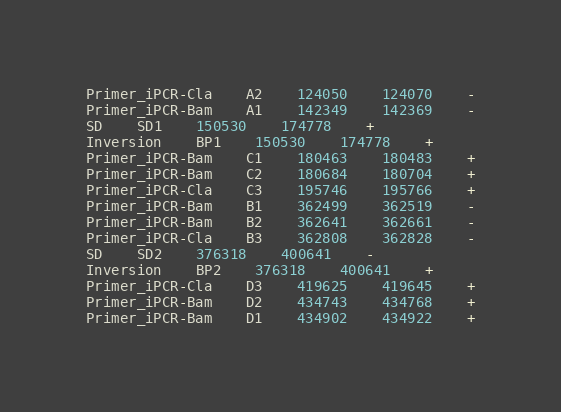<code> <loc_0><loc_0><loc_500><loc_500><_SQL_>Primer_iPCR-Cla	A2	124050	124070	-
Primer_iPCR-Bam	A1	142349	142369	-
SD	SD1	150530	174778	+
Inversion	BP1	150530	174778	+
Primer_iPCR-Bam	C1	180463	180483	+
Primer_iPCR-Bam	C2	180684	180704	+
Primer_iPCR-Cla	C3	195746	195766	+
Primer_iPCR-Bam	B1	362499	362519	-
Primer_iPCR-Bam	B2	362641	362661	-
Primer_iPCR-Cla	B3	362808	362828	-
SD	SD2	376318	400641	-
Inversion	BP2	376318	400641	+
Primer_iPCR-Cla	D3	419625	419645	+
Primer_iPCR-Bam	D2	434743	434768	+
Primer_iPCR-Bam	D1	434902	434922	+
</code> 